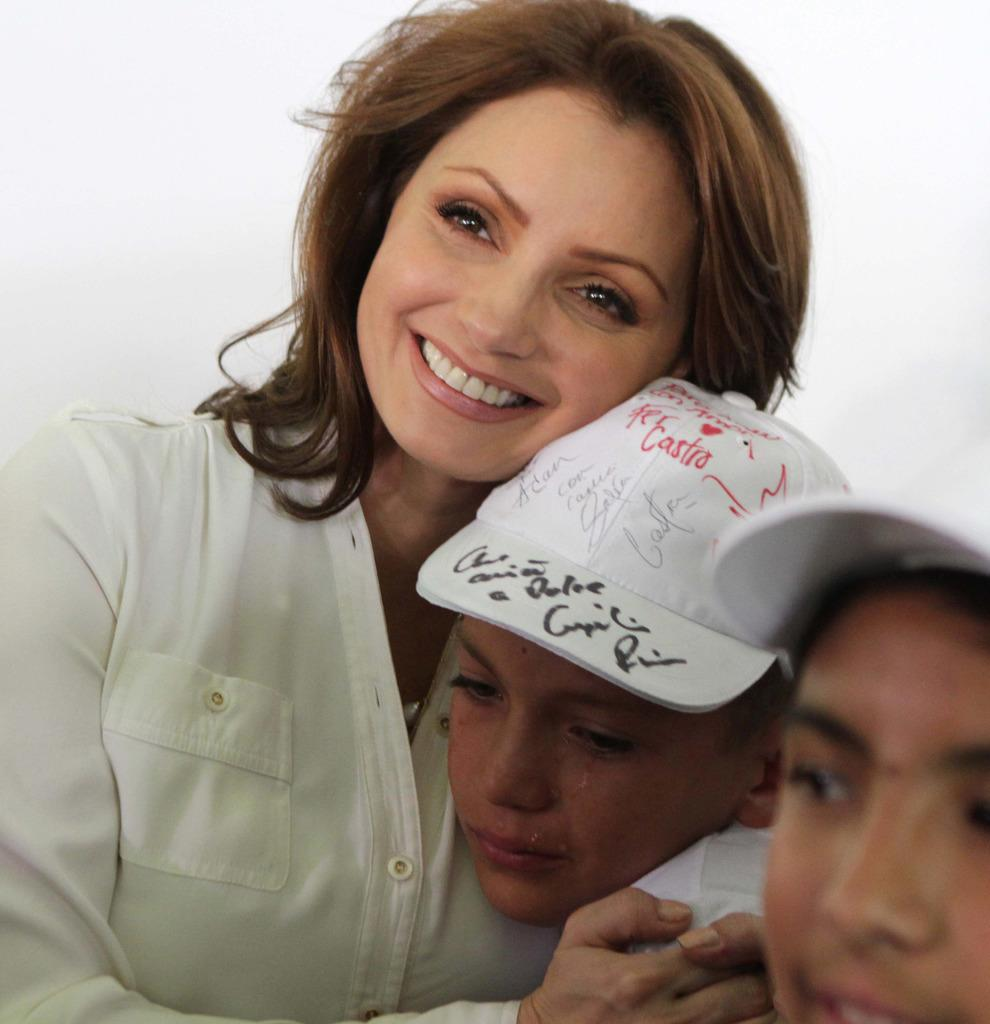What are the people in the image doing? The people in the image are sitting. Can you describe the emotions of the people in the image? Some of the people are crying, while others are smiling. What type of idea is being developed in the image? There is no reference to an idea or development in the image; it features people sitting with various emotional expressions. Where is the vase located in the image? There is no vase present in the image. 